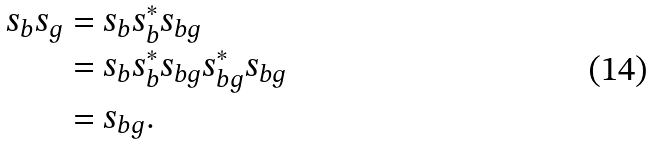Convert formula to latex. <formula><loc_0><loc_0><loc_500><loc_500>s _ { b } s _ { g } & = s _ { b } s _ { b } ^ { * } s _ { b g } \\ & = s _ { b } s _ { b } ^ { * } s _ { b g } s _ { b g } ^ { * } s _ { b g } \\ & = s _ { b g } .</formula> 